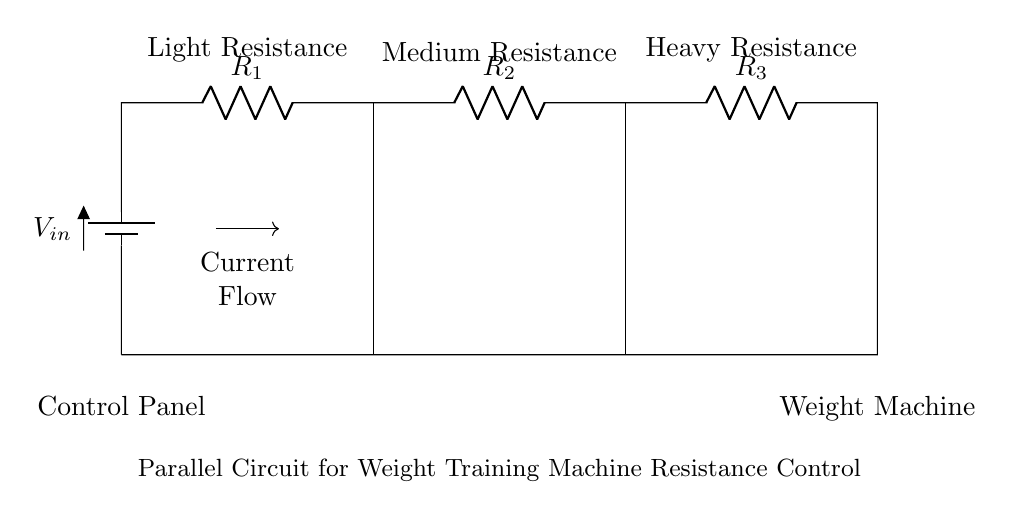What type of circuit is represented? The circuit is a parallel circuit, as indicated by the multiple paths for current to flow through different resistors connected alongside each other.
Answer: Parallel How many resistors are in the circuit? There are three resistors in the circuit, each labeled as R1, R2, and R3, showing that they are all present in the circuit diagram.
Answer: Three What is the function of the control panel? The control panel is used to adjust the resistance settings for the weight training machine, controlling how much resistance the user faces during their workout.
Answer: Resistance control Which resistor represents the highest resistance? The heavy resistance is found on the far right side of the diagram and is indicated by R3, which is labeled as such.
Answer: Heavy Resistance What happens to current as it splits among the resistors? The current divides among the parallel resistors, with each resistor allowing a portion of the current to pass through depending on its resistance value.
Answer: Splits If one resistor fails, what happens to the circuit? In a parallel circuit, if one resistor fails, the other resistors continue to function, allowing the circuit to remain operational.
Answer: Remains operational 